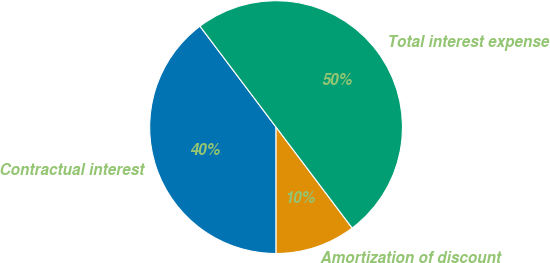<chart> <loc_0><loc_0><loc_500><loc_500><pie_chart><fcel>Contractual interest<fcel>Amortization of discount<fcel>Total interest expense<nl><fcel>39.72%<fcel>10.28%<fcel>50.0%<nl></chart> 